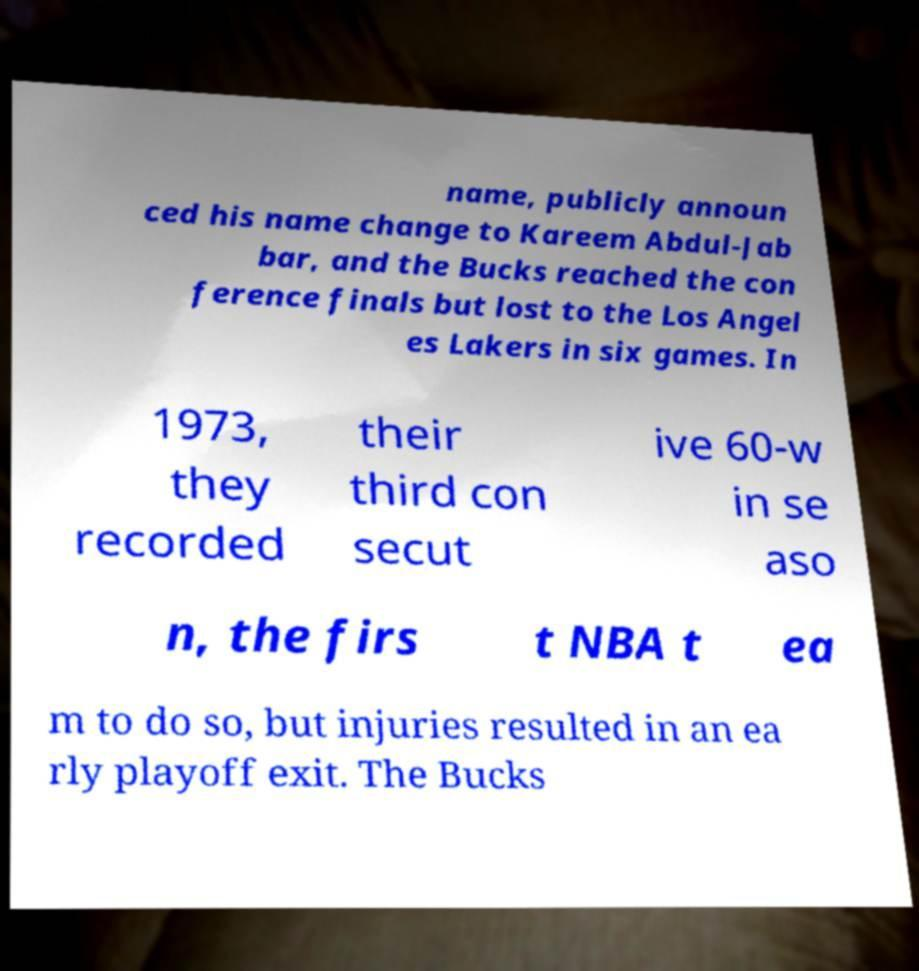Could you assist in decoding the text presented in this image and type it out clearly? name, publicly announ ced his name change to Kareem Abdul-Jab bar, and the Bucks reached the con ference finals but lost to the Los Angel es Lakers in six games. In 1973, they recorded their third con secut ive 60-w in se aso n, the firs t NBA t ea m to do so, but injuries resulted in an ea rly playoff exit. The Bucks 